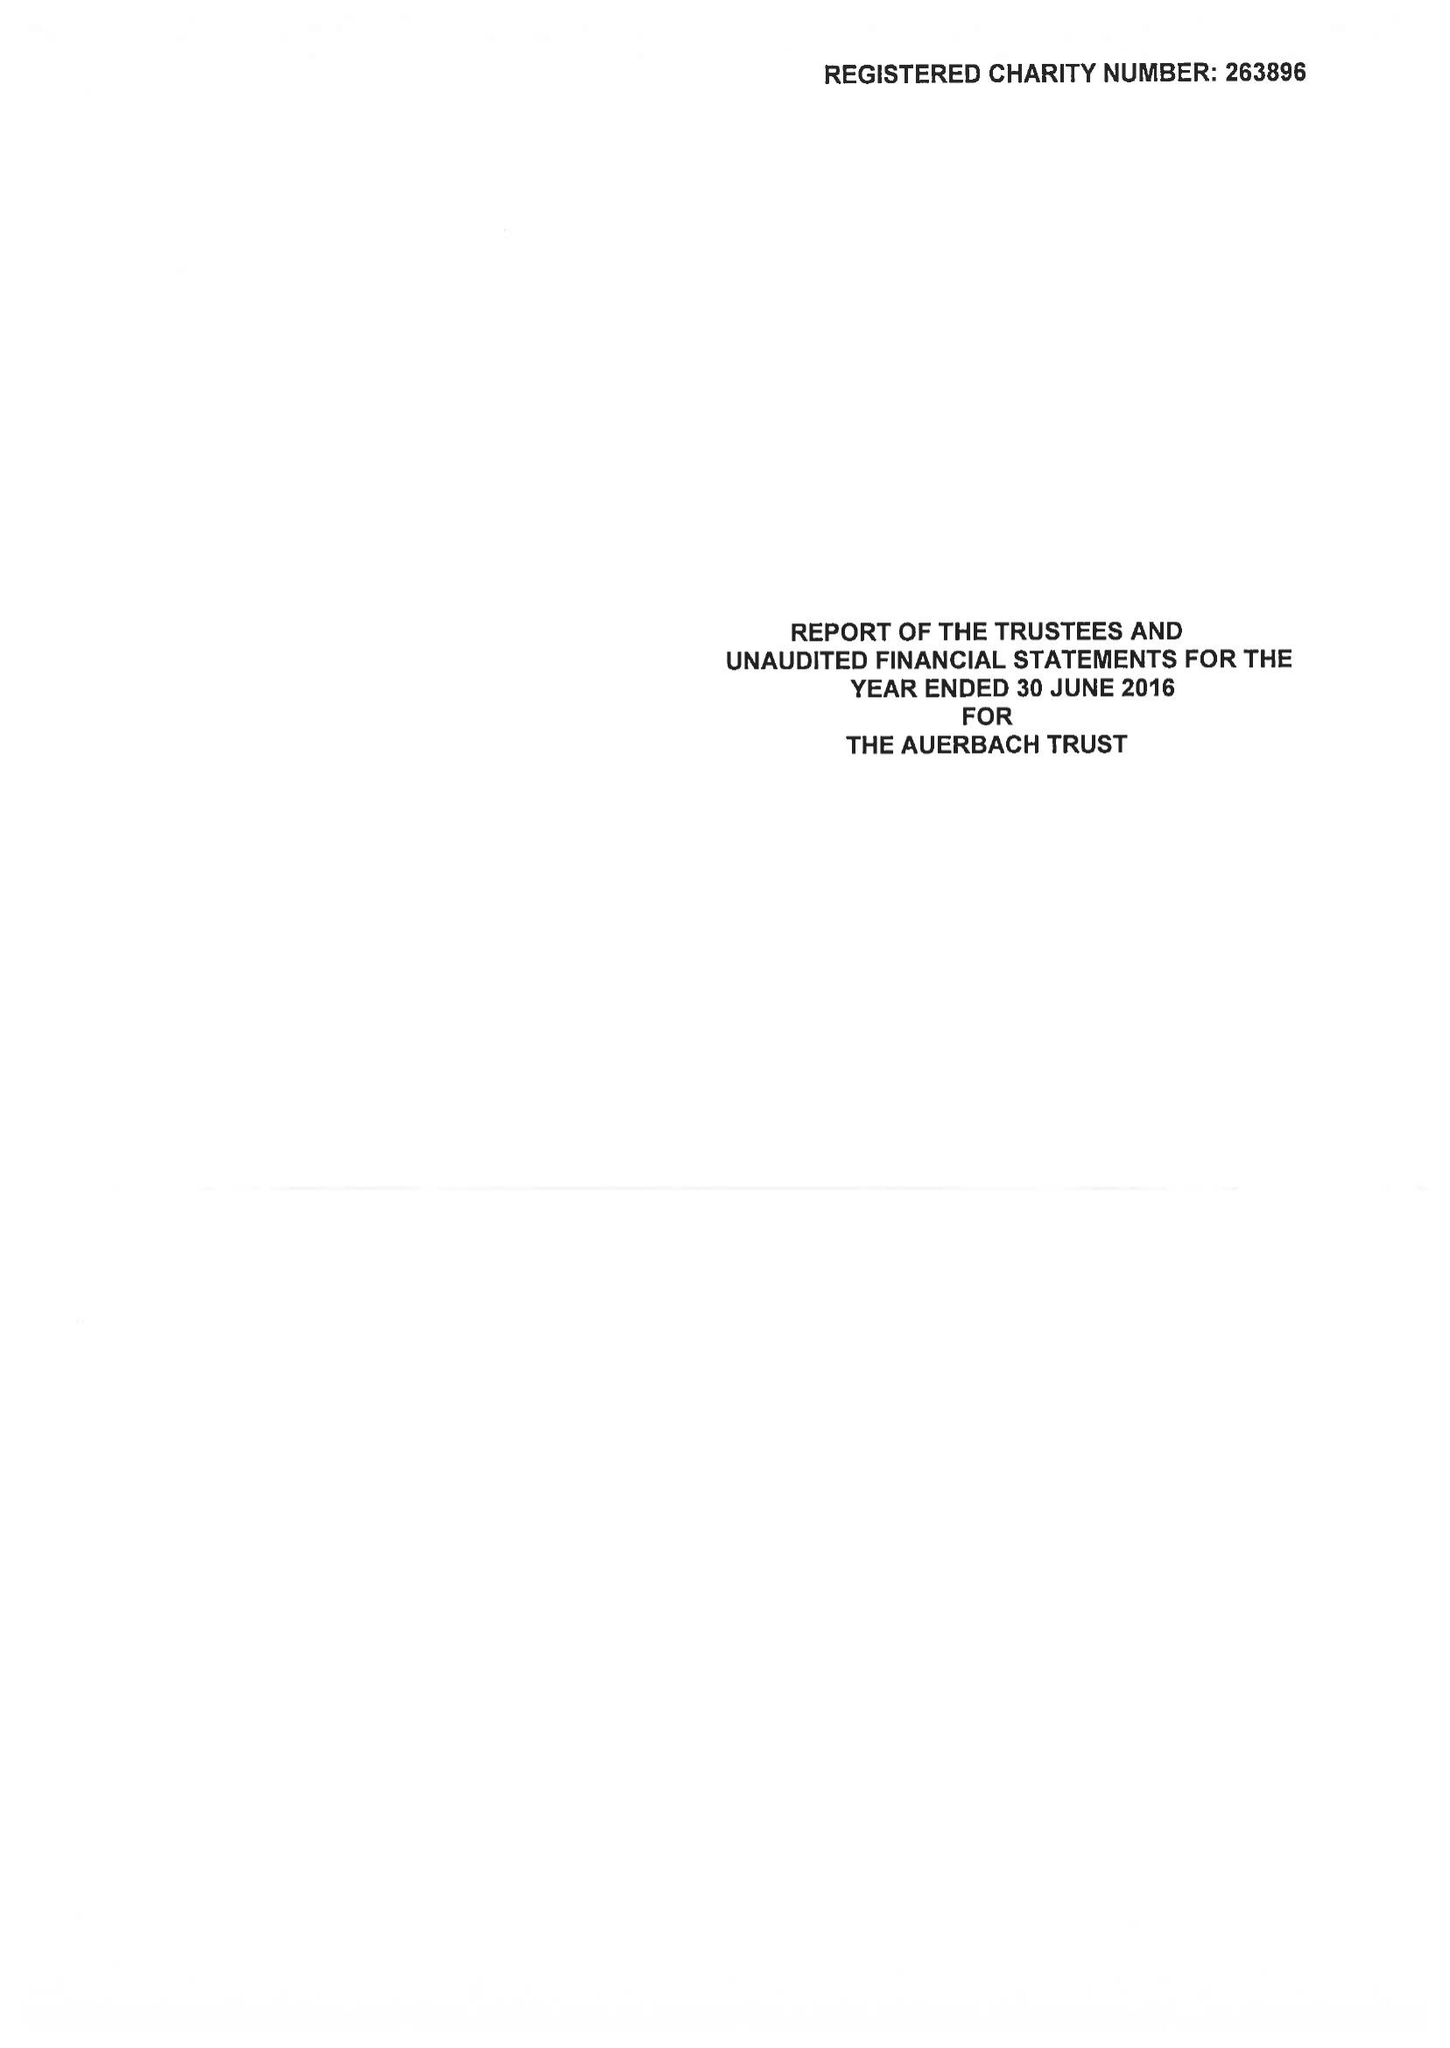What is the value for the charity_name?
Answer the question using a single word or phrase. The Auerbach Trust 